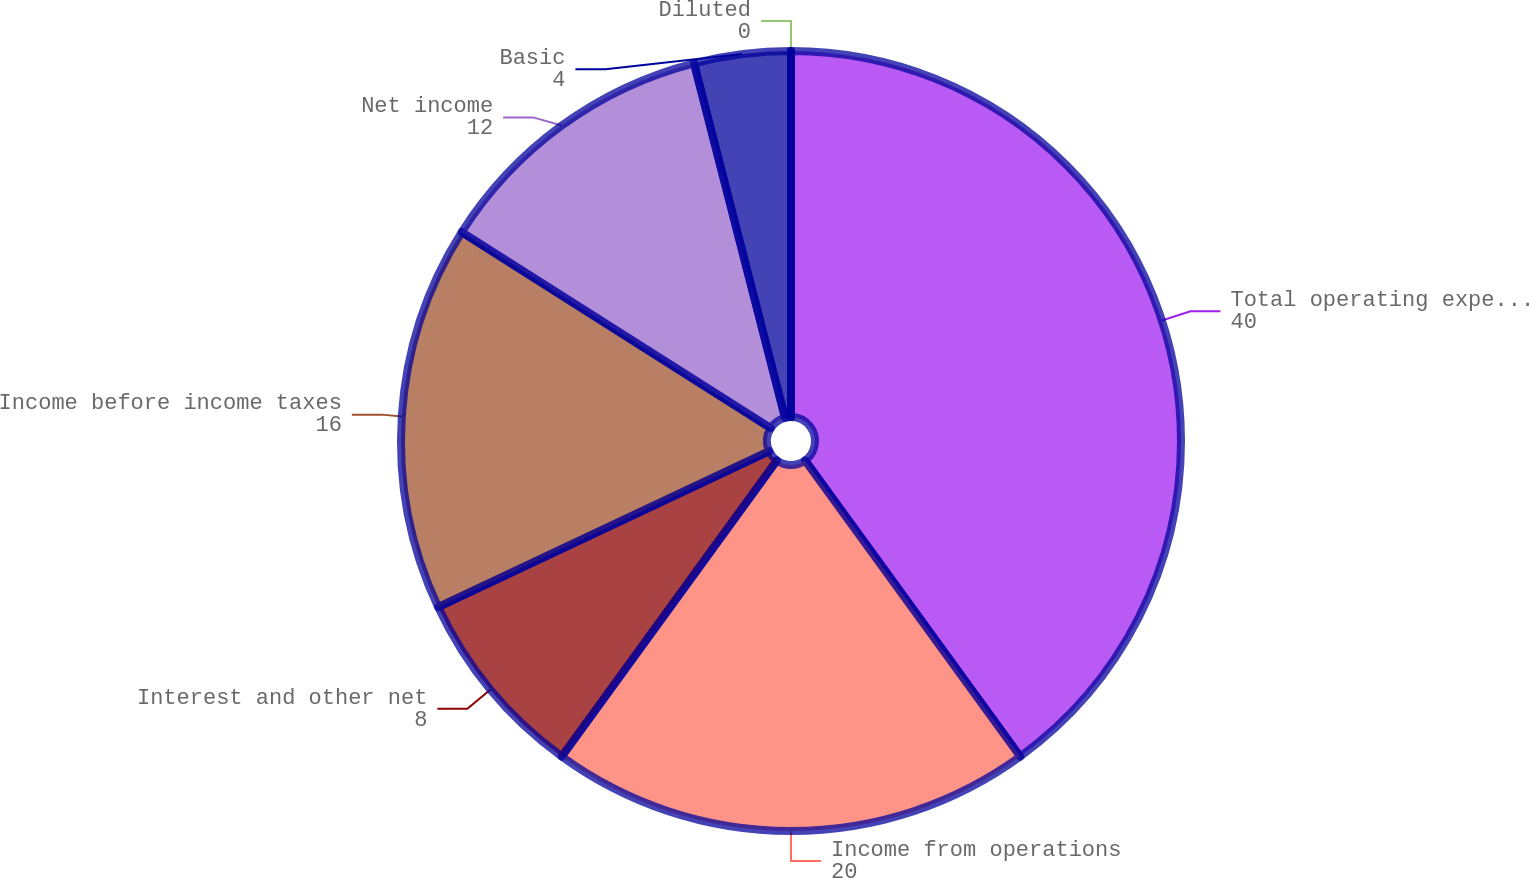Convert chart to OTSL. <chart><loc_0><loc_0><loc_500><loc_500><pie_chart><fcel>Total operating expenses<fcel>Income from operations<fcel>Interest and other net<fcel>Income before income taxes<fcel>Net income<fcel>Basic<fcel>Diluted<nl><fcel>40.0%<fcel>20.0%<fcel>8.0%<fcel>16.0%<fcel>12.0%<fcel>4.0%<fcel>0.0%<nl></chart> 